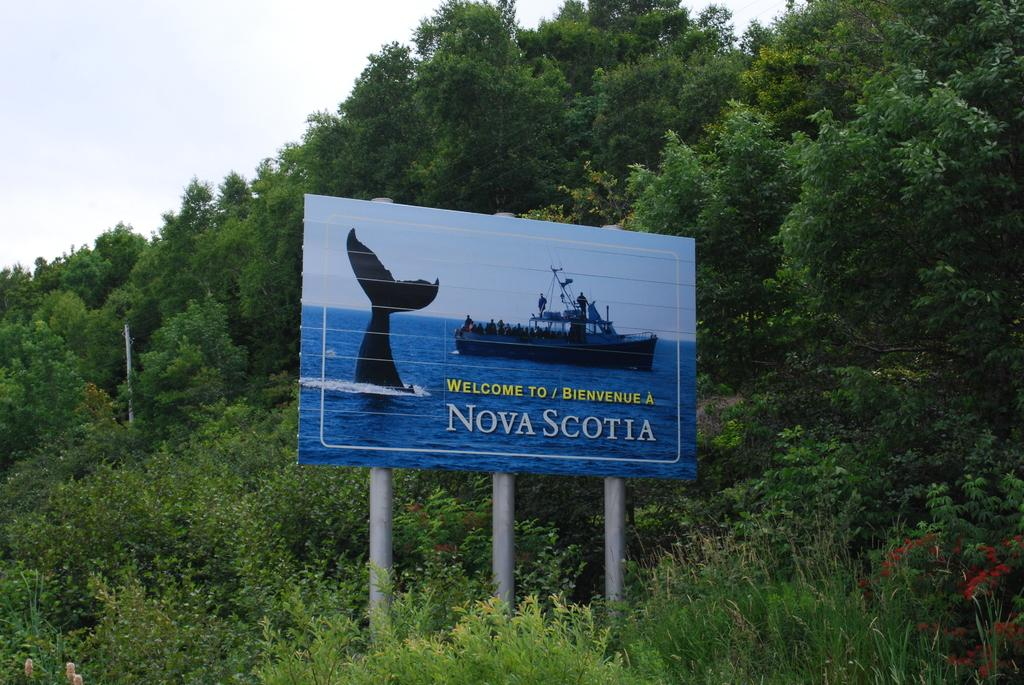What objects are made of metal in the image? There are three metal poles in the image. What is attached to the metal poles? There is a board attached to the metal poles. What type of vegetation can be seen in the image? There are green trees in the image. What is visible in the background of the image? The sky is visible in the background of the image. What type of writing can be seen on the board in the image? There is no writing visible on the board in the image. What emotions are the green trees feeling in the image? Trees do not have emotions, so this question cannot be answered. 